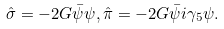Convert formula to latex. <formula><loc_0><loc_0><loc_500><loc_500>\hat { \sigma } = - 2 G \bar { \psi } \psi , \hat { \pi } = - 2 G \bar { \psi } i \gamma _ { 5 } \psi .</formula> 